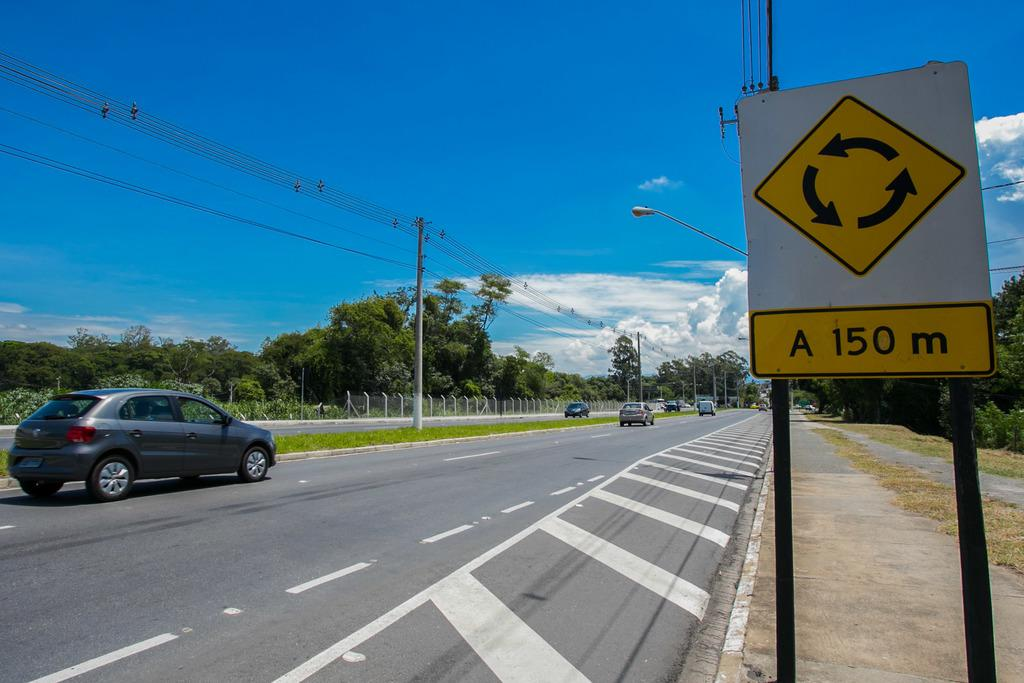<image>
Describe the image concisely. A sign says a roundabout is 150 meters ahead. 